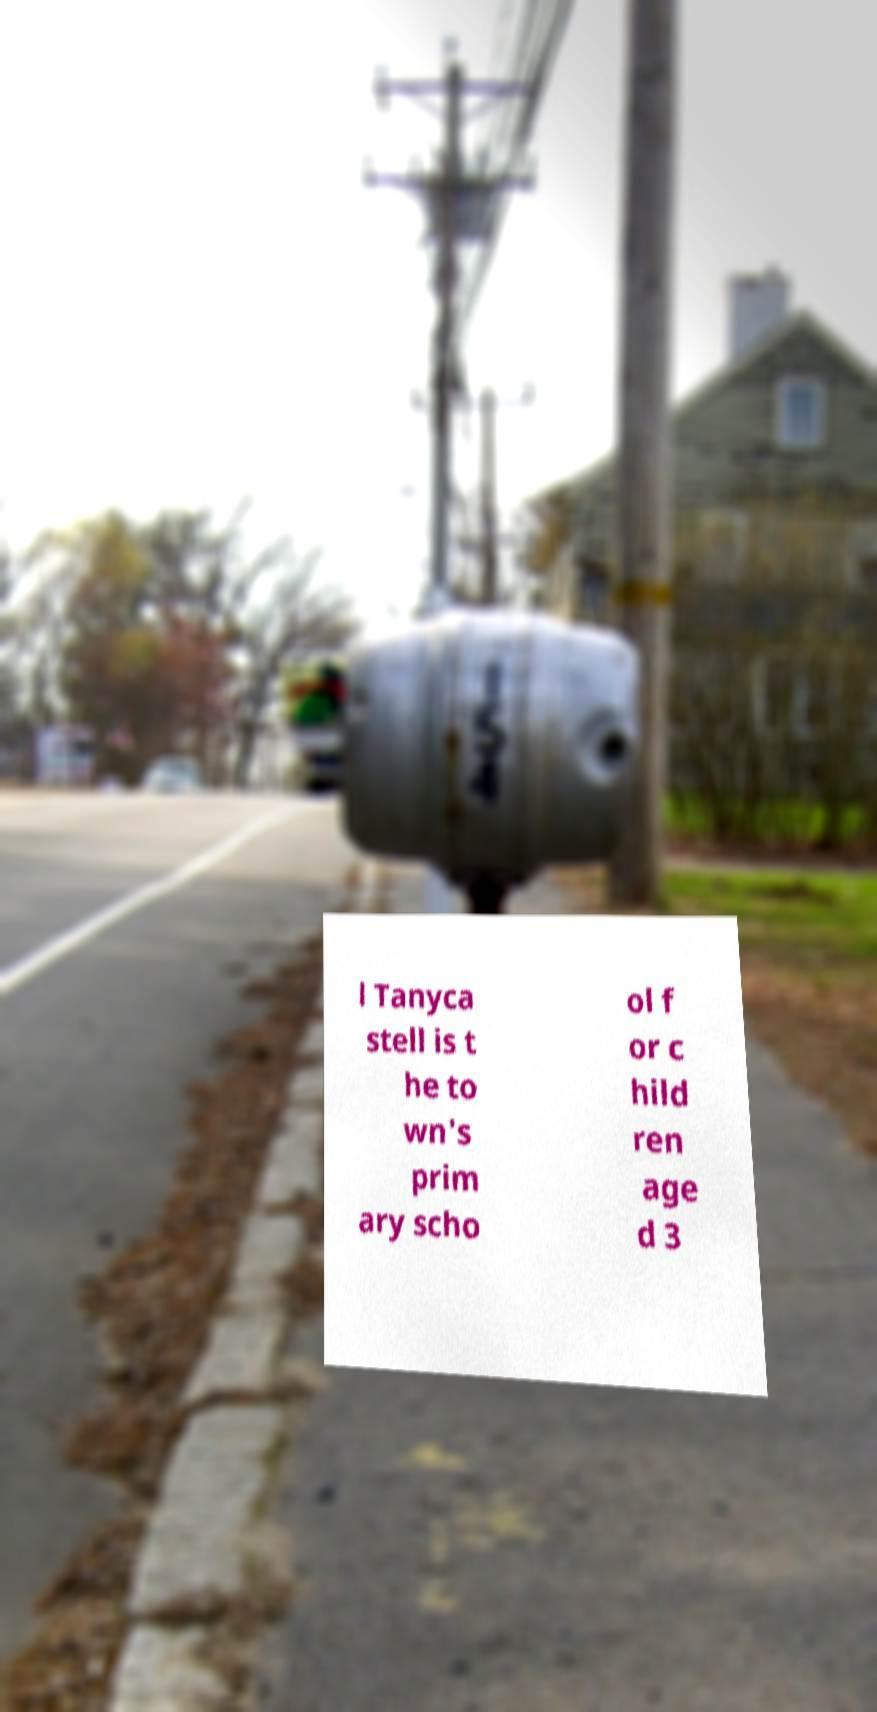Please identify and transcribe the text found in this image. l Tanyca stell is t he to wn's prim ary scho ol f or c hild ren age d 3 